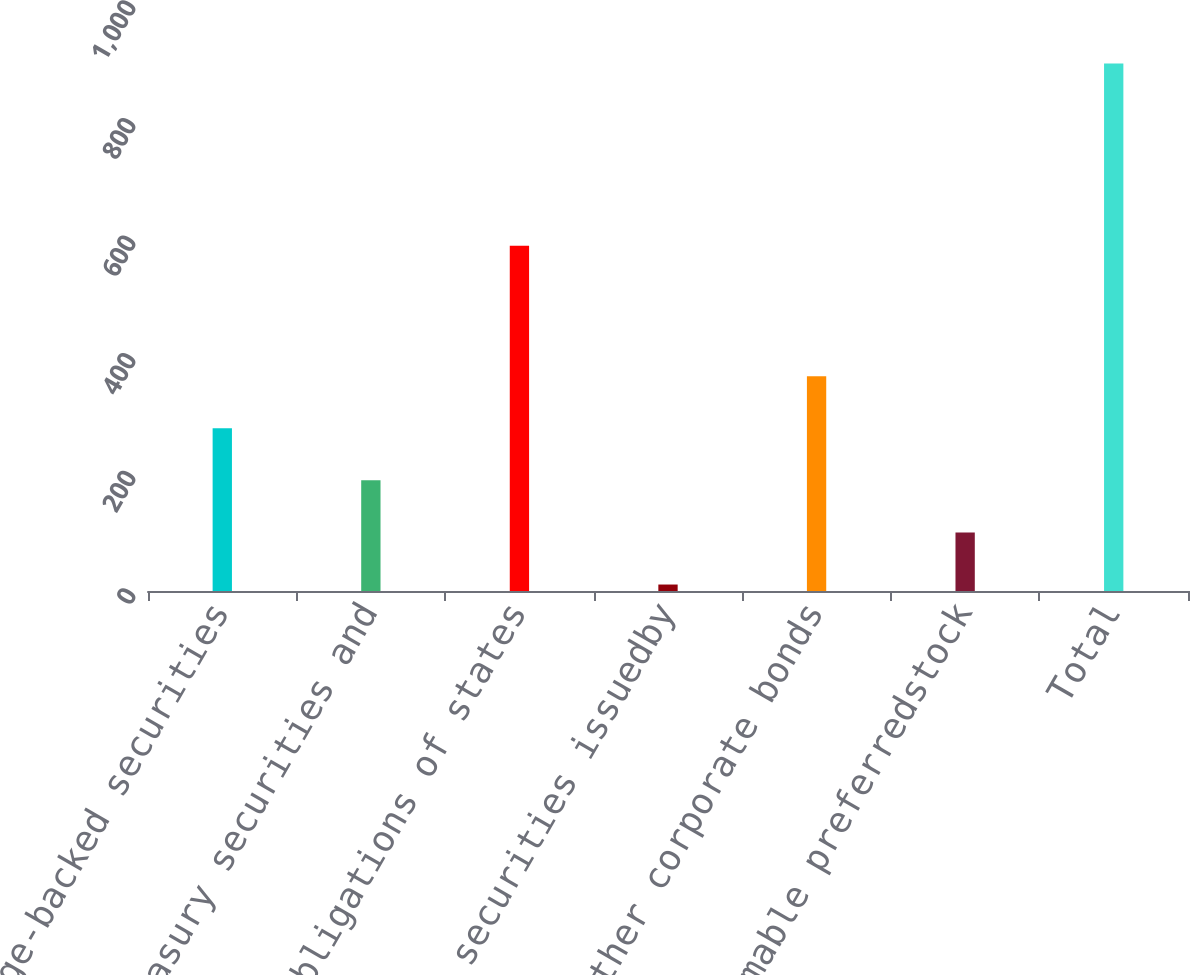Convert chart to OTSL. <chart><loc_0><loc_0><loc_500><loc_500><bar_chart><fcel>Mortgage-backed securities<fcel>US Treasury securities and<fcel>Obligations of states<fcel>Debt securities issuedby<fcel>All other corporate bonds<fcel>Redeemable preferredstock<fcel>Total<nl><fcel>276.8<fcel>188.2<fcel>587<fcel>11<fcel>365.4<fcel>99.6<fcel>897<nl></chart> 